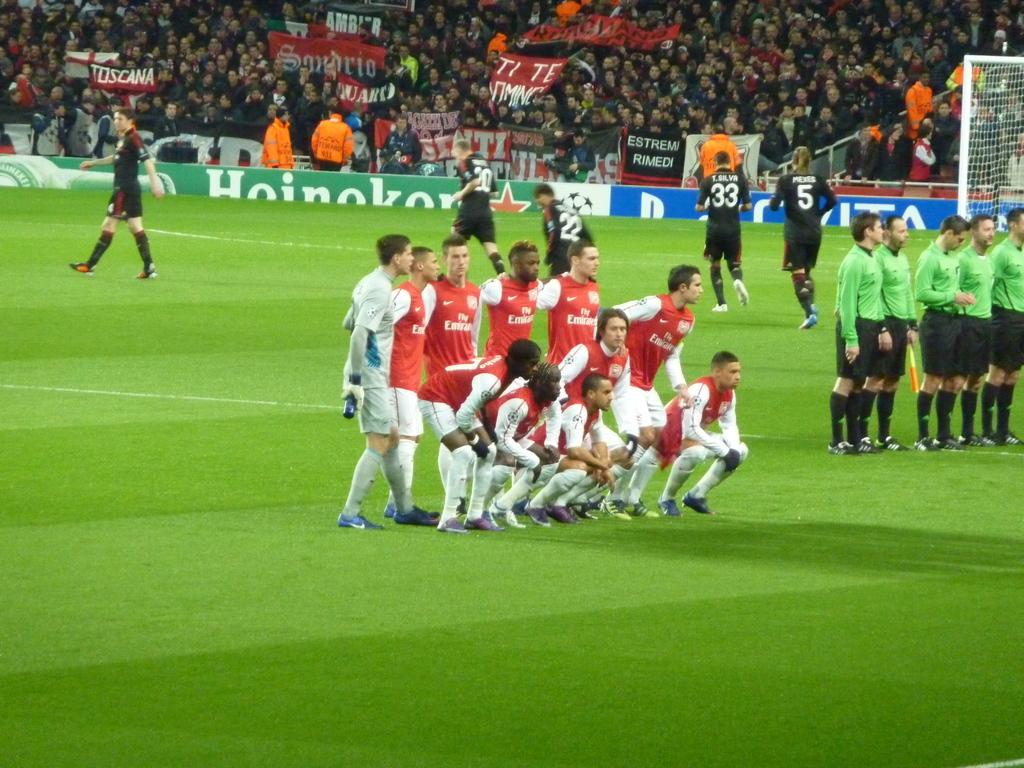<image>
Offer a succinct explanation of the picture presented. A team of players are huddled together with fly Emirates on their jerseys. 